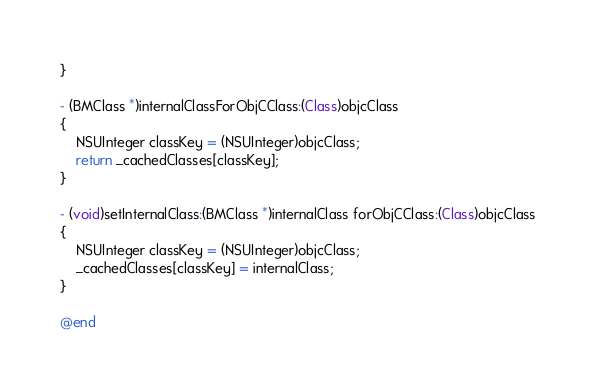Convert code to text. <code><loc_0><loc_0><loc_500><loc_500><_ObjectiveC_>}

- (BMClass *)internalClassForObjCClass:(Class)objcClass
{
    NSUInteger classKey = (NSUInteger)objcClass;
    return _cachedClasses[classKey];
}

- (void)setInternalClass:(BMClass *)internalClass forObjCClass:(Class)objcClass
{
    NSUInteger classKey = (NSUInteger)objcClass;
    _cachedClasses[classKey] = internalClass;
}

@end
</code> 